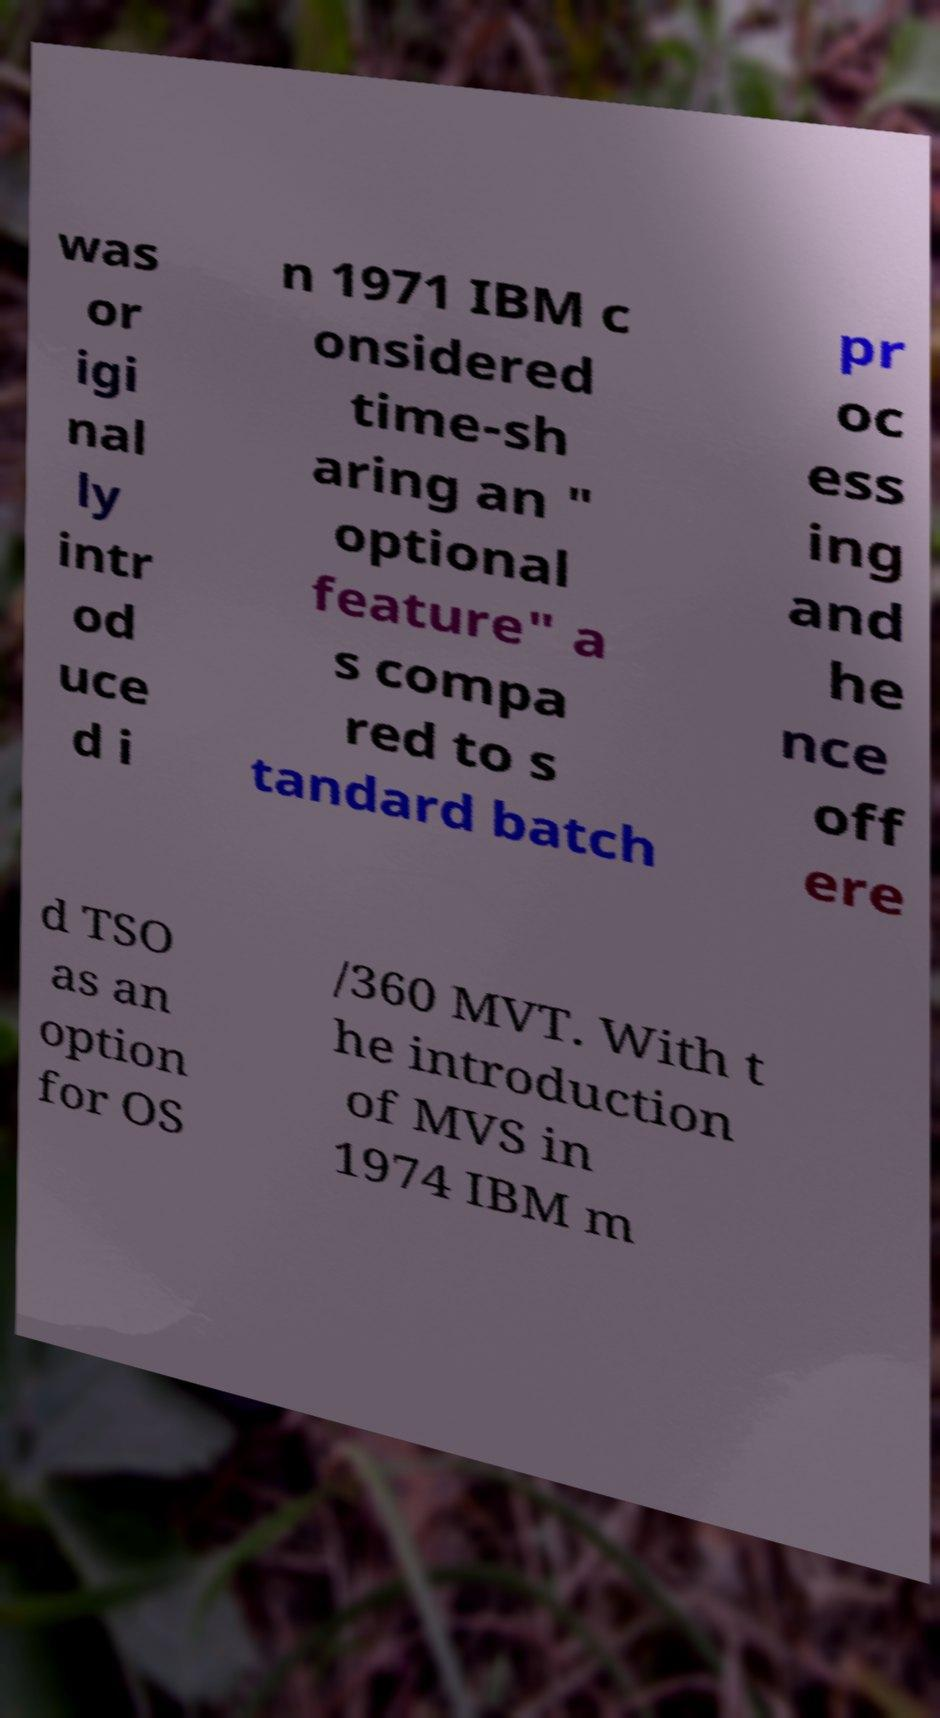For documentation purposes, I need the text within this image transcribed. Could you provide that? was or igi nal ly intr od uce d i n 1971 IBM c onsidered time-sh aring an " optional feature" a s compa red to s tandard batch pr oc ess ing and he nce off ere d TSO as an option for OS /360 MVT. With t he introduction of MVS in 1974 IBM m 